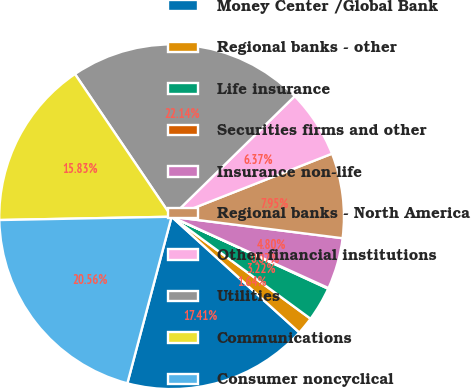Convert chart to OTSL. <chart><loc_0><loc_0><loc_500><loc_500><pie_chart><fcel>Money Center /Global Bank<fcel>Regional banks - other<fcel>Life insurance<fcel>Securities firms and other<fcel>Insurance non-life<fcel>Regional banks - North America<fcel>Other financial institutions<fcel>Utilities<fcel>Communications<fcel>Consumer noncyclical<nl><fcel>17.41%<fcel>1.64%<fcel>3.22%<fcel>0.07%<fcel>4.8%<fcel>7.95%<fcel>6.37%<fcel>22.14%<fcel>15.83%<fcel>20.56%<nl></chart> 